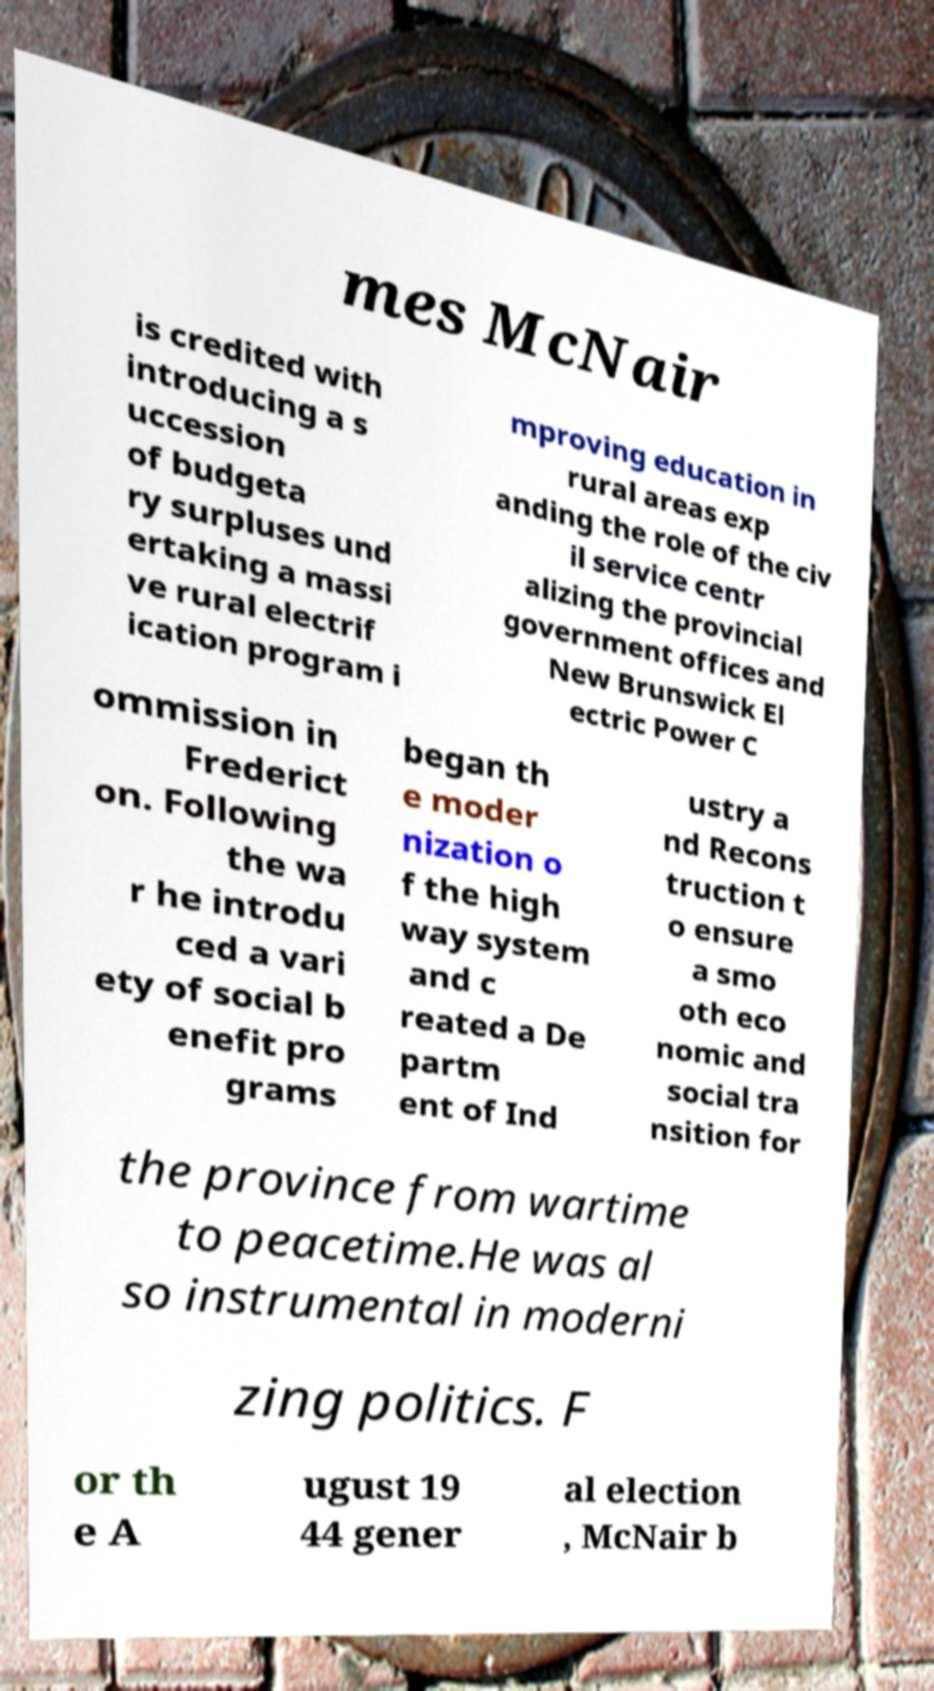Could you extract and type out the text from this image? mes McNair is credited with introducing a s uccession of budgeta ry surpluses und ertaking a massi ve rural electrif ication program i mproving education in rural areas exp anding the role of the civ il service centr alizing the provincial government offices and New Brunswick El ectric Power C ommission in Frederict on. Following the wa r he introdu ced a vari ety of social b enefit pro grams began th e moder nization o f the high way system and c reated a De partm ent of Ind ustry a nd Recons truction t o ensure a smo oth eco nomic and social tra nsition for the province from wartime to peacetime.He was al so instrumental in moderni zing politics. F or th e A ugust 19 44 gener al election , McNair b 